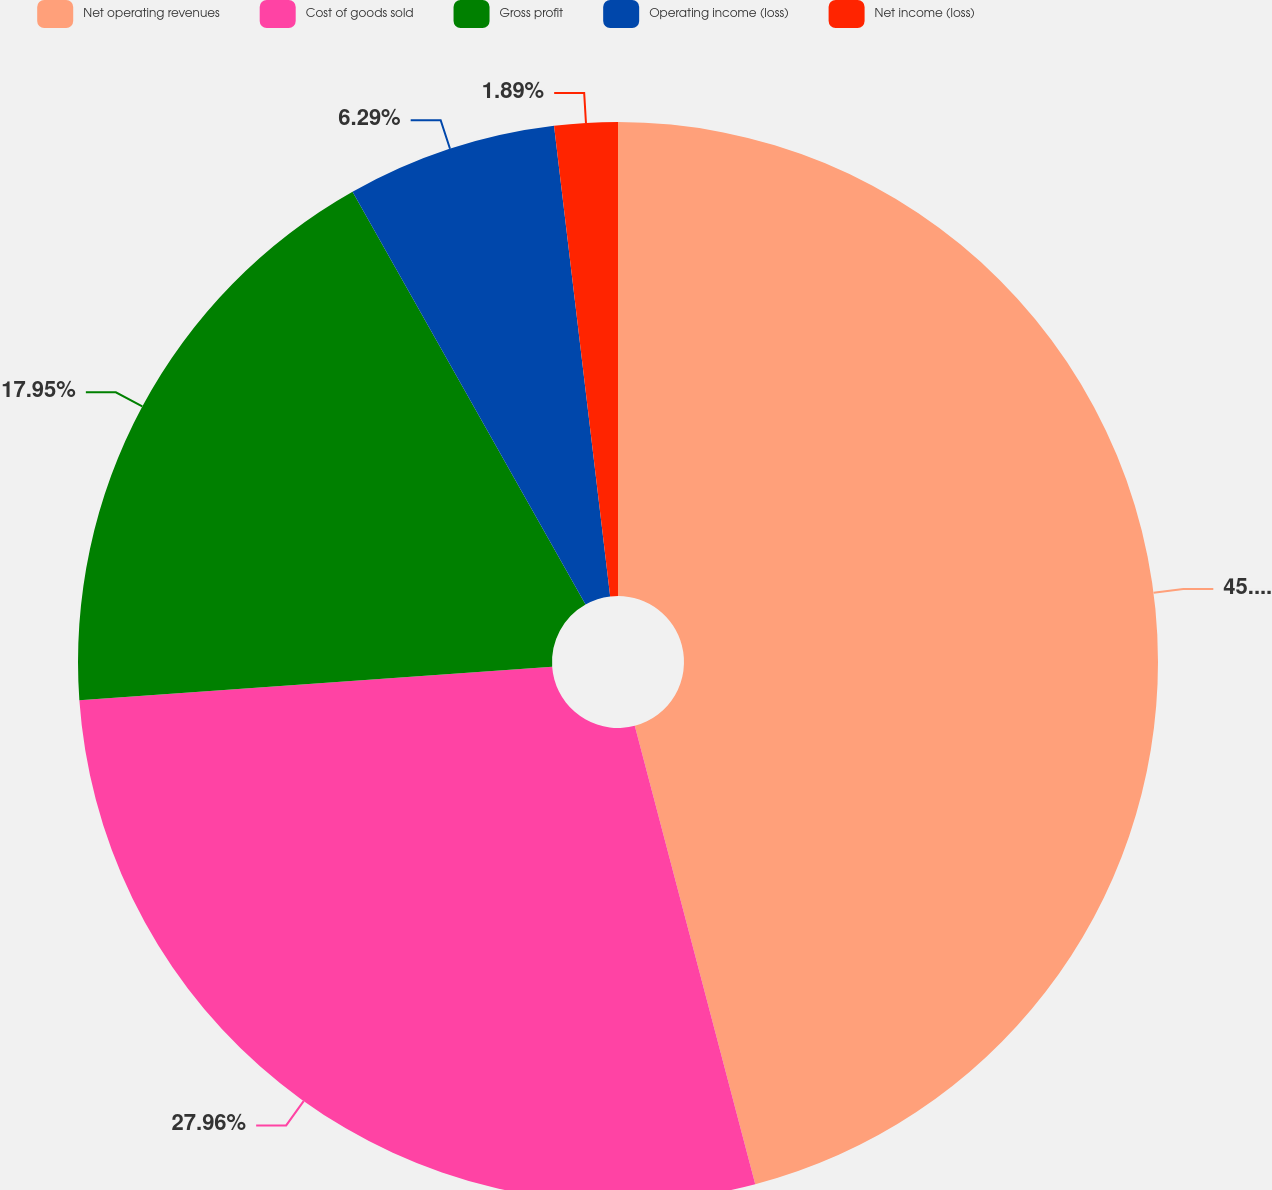Convert chart to OTSL. <chart><loc_0><loc_0><loc_500><loc_500><pie_chart><fcel>Net operating revenues<fcel>Cost of goods sold<fcel>Gross profit<fcel>Operating income (loss)<fcel>Net income (loss)<nl><fcel>45.91%<fcel>27.96%<fcel>17.95%<fcel>6.29%<fcel>1.89%<nl></chart> 